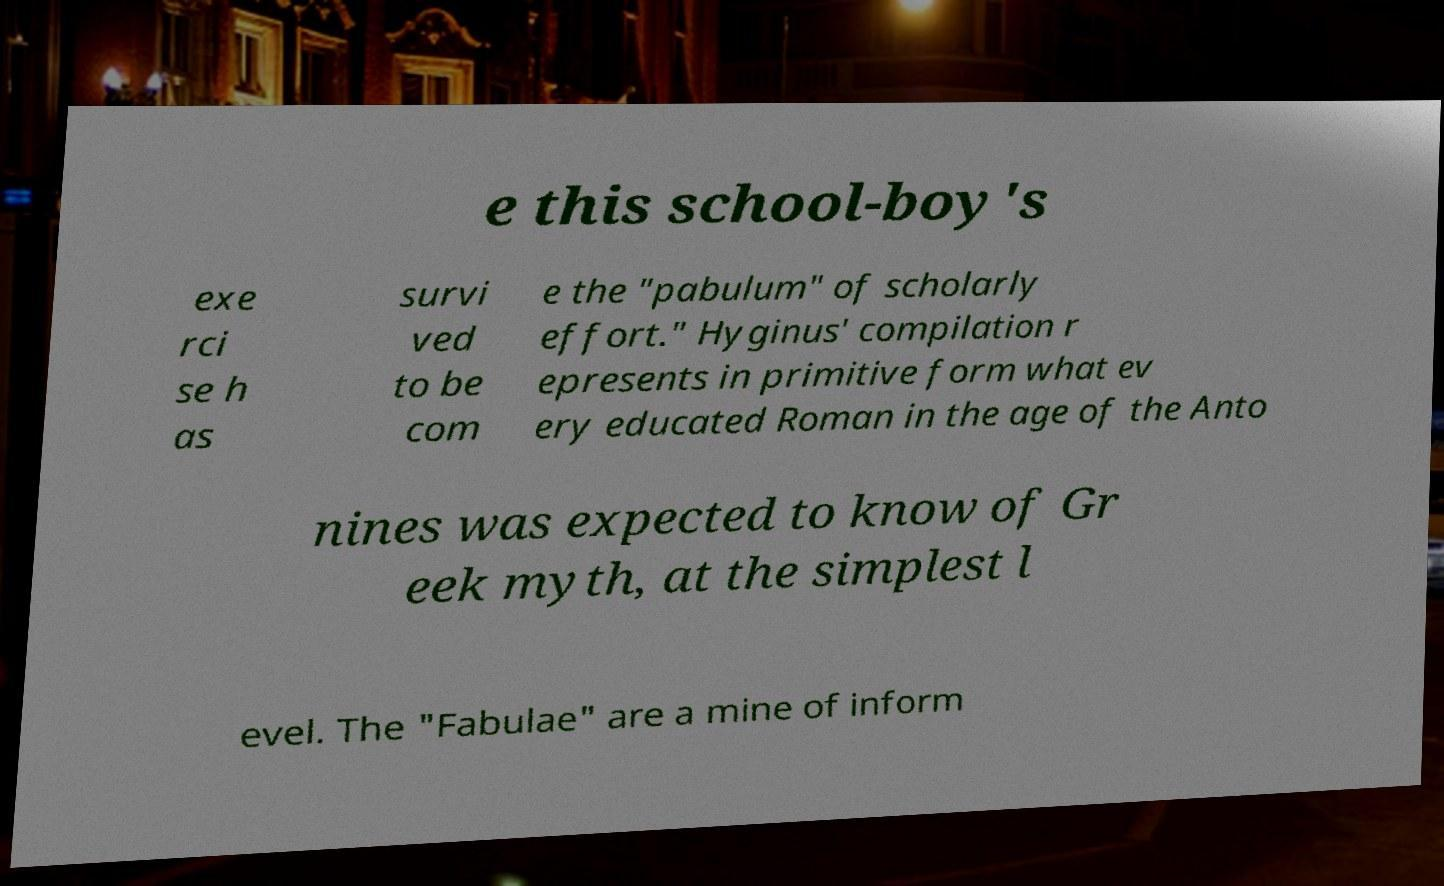Please read and relay the text visible in this image. What does it say? e this school-boy's exe rci se h as survi ved to be com e the "pabulum" of scholarly effort." Hyginus' compilation r epresents in primitive form what ev ery educated Roman in the age of the Anto nines was expected to know of Gr eek myth, at the simplest l evel. The "Fabulae" are a mine of inform 